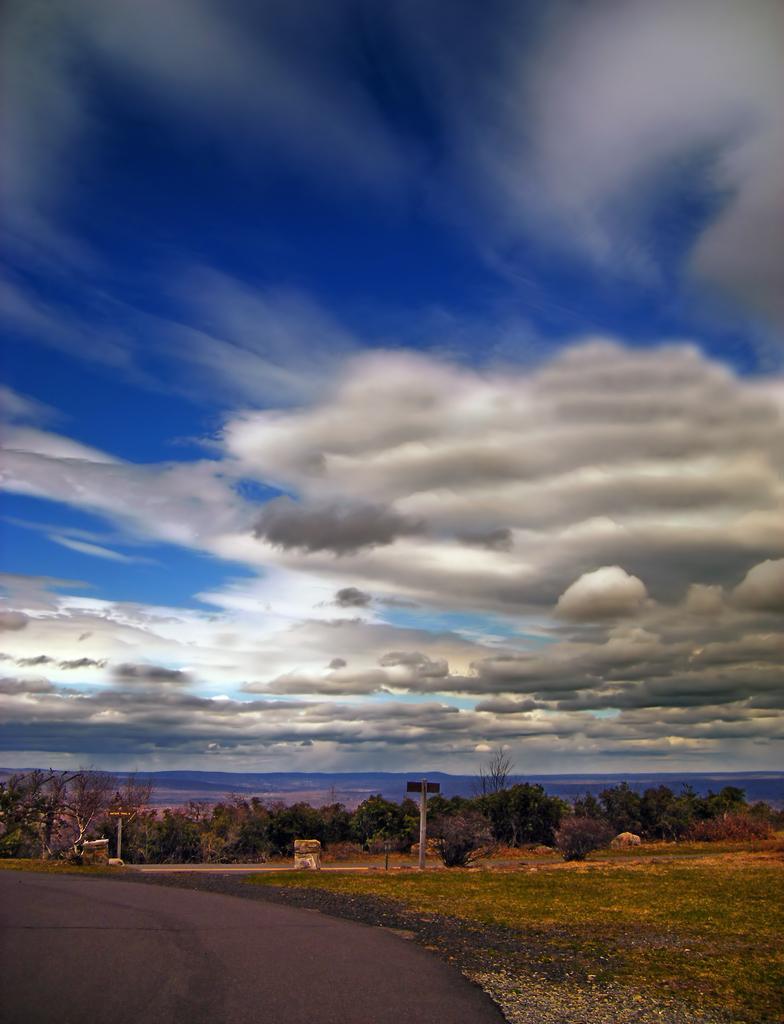In one or two sentences, can you explain what this image depicts? In this picture we can see a road and poles. Behind the poles there are trees and a cloudy sky. 